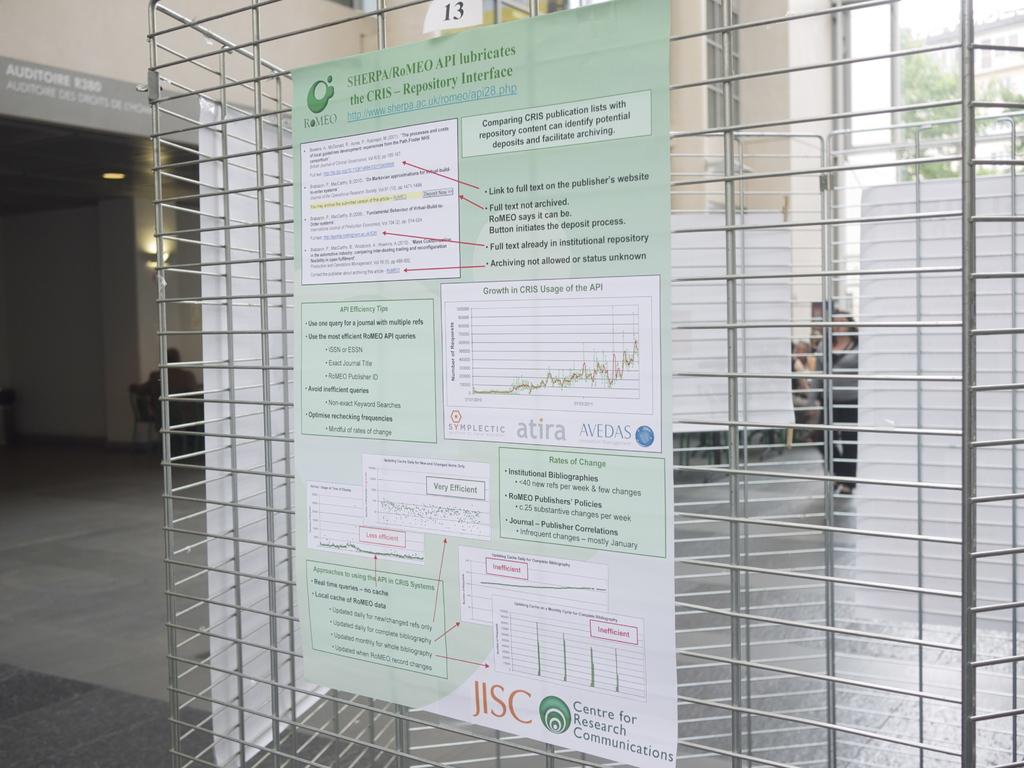Is atria on one of the charts?
Provide a short and direct response. Yes. What does this center research?
Give a very brief answer. Communications. 